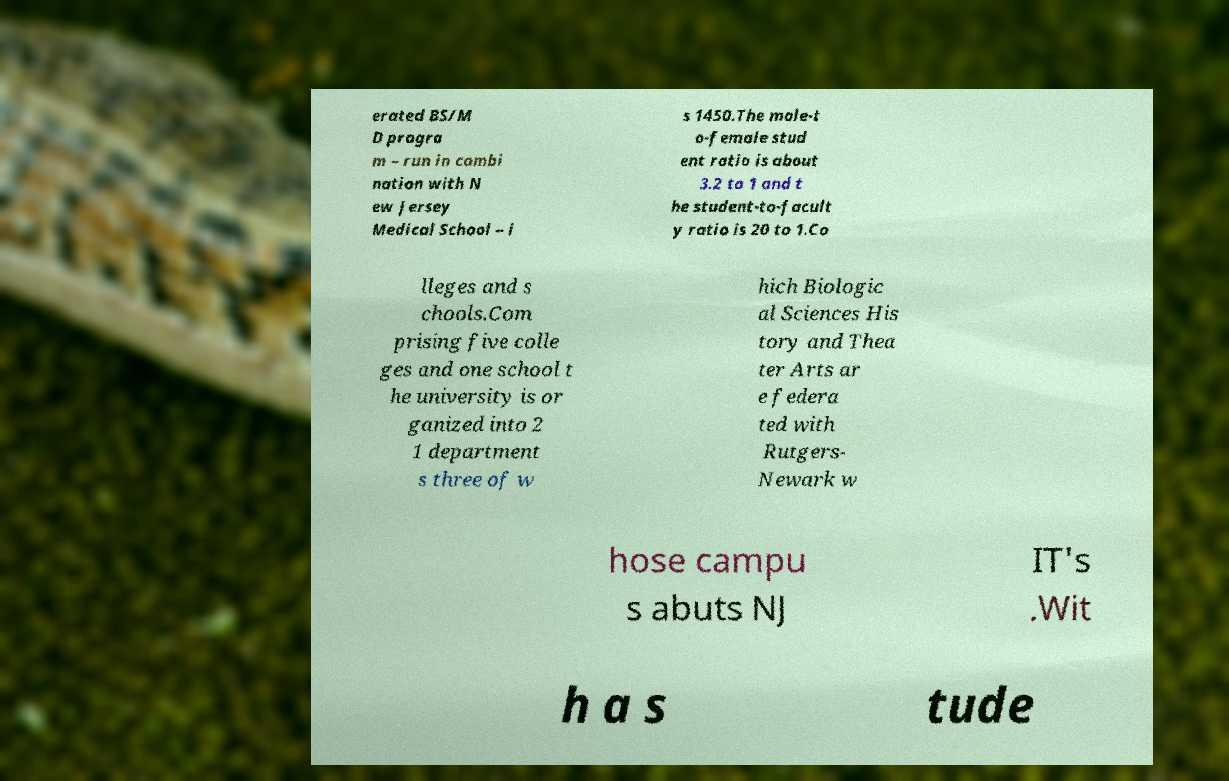There's text embedded in this image that I need extracted. Can you transcribe it verbatim? erated BS/M D progra m – run in combi nation with N ew Jersey Medical School – i s 1450.The male-t o-female stud ent ratio is about 3.2 to 1 and t he student-to-facult y ratio is 20 to 1.Co lleges and s chools.Com prising five colle ges and one school t he university is or ganized into 2 1 department s three of w hich Biologic al Sciences His tory and Thea ter Arts ar e federa ted with Rutgers- Newark w hose campu s abuts NJ IT's .Wit h a s tude 